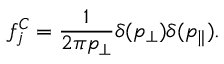<formula> <loc_0><loc_0><loc_500><loc_500>f _ { j } ^ { C } = \frac { 1 } { 2 \pi p _ { \perp } } \delta ( p _ { \perp } ) \delta ( p _ { \| } ) .</formula> 